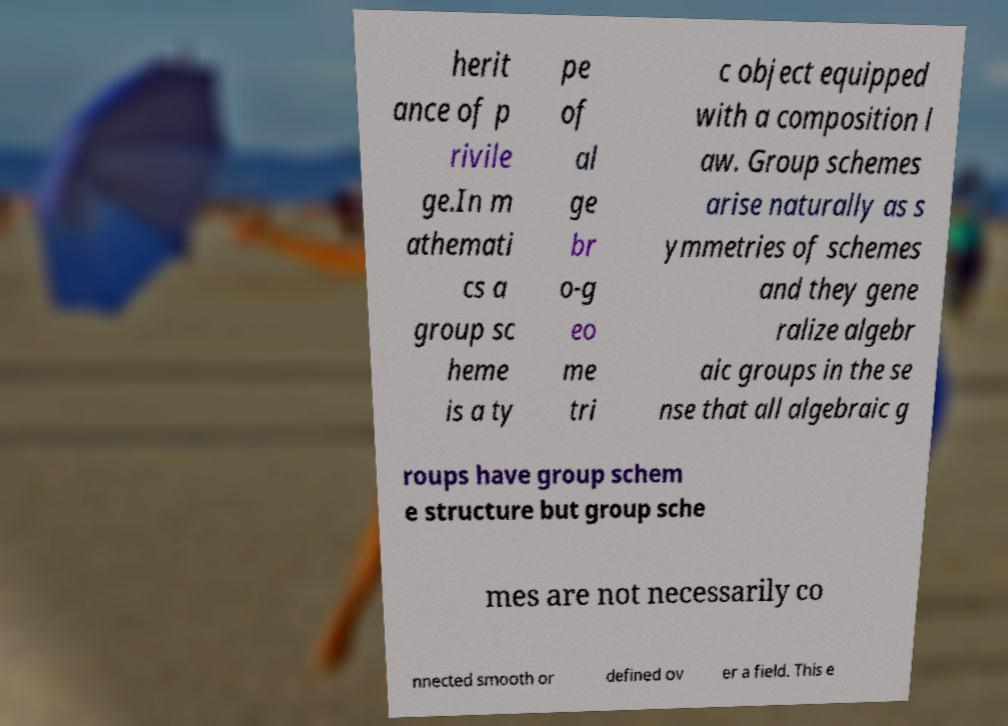Please read and relay the text visible in this image. What does it say? herit ance of p rivile ge.In m athemati cs a group sc heme is a ty pe of al ge br o-g eo me tri c object equipped with a composition l aw. Group schemes arise naturally as s ymmetries of schemes and they gene ralize algebr aic groups in the se nse that all algebraic g roups have group schem e structure but group sche mes are not necessarily co nnected smooth or defined ov er a field. This e 